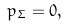Convert formula to latex. <formula><loc_0><loc_0><loc_500><loc_500>p _ { \Sigma } = 0 ,</formula> 